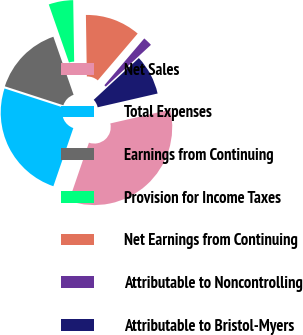Convert chart to OTSL. <chart><loc_0><loc_0><loc_500><loc_500><pie_chart><fcel>Net Sales<fcel>Total Expenses<fcel>Earnings from Continuing<fcel>Provision for Income Taxes<fcel>Net Earnings from Continuing<fcel>Attributable to Noncontrolling<fcel>Attributable to Bristol-Myers<nl><fcel>33.86%<fcel>24.73%<fcel>14.68%<fcel>5.09%<fcel>11.48%<fcel>1.89%<fcel>8.28%<nl></chart> 